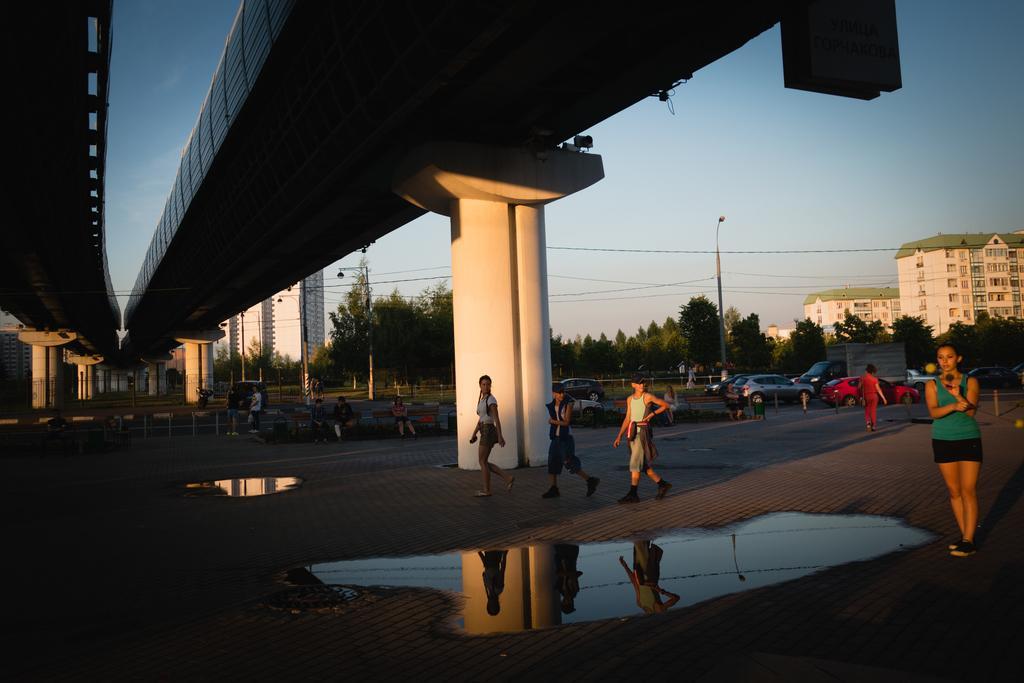Can you describe this image briefly? In this image there is flyover, a few people on the road, few lights attached to the poles, a few cables, vehicles, few buildings and the sky, there we can see some water on the road. 